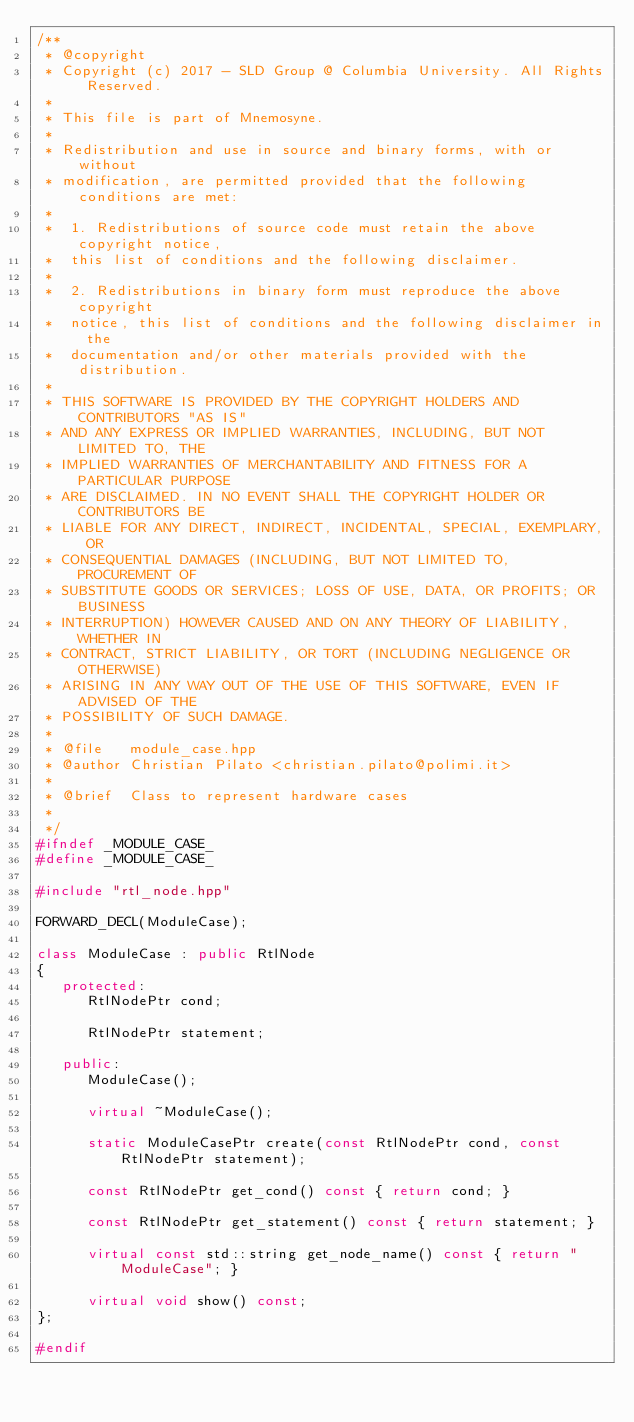<code> <loc_0><loc_0><loc_500><loc_500><_C++_>/**
 * @copyright
 * Copyright (c) 2017 - SLD Group @ Columbia University. All Rights Reserved.
 *
 * This file is part of Mnemosyne.
 *
 * Redistribution and use in source and binary forms, with or without
 * modification, are permitted provided that the following conditions are met:
 *
 *  1. Redistributions of source code must retain the above copyright notice,
 *  this list of conditions and the following disclaimer.
 *
 *  2. Redistributions in binary form must reproduce the above copyright
 *  notice, this list of conditions and the following disclaimer in the
 *  documentation and/or other materials provided with the distribution.
 *
 * THIS SOFTWARE IS PROVIDED BY THE COPYRIGHT HOLDERS AND CONTRIBUTORS "AS IS"
 * AND ANY EXPRESS OR IMPLIED WARRANTIES, INCLUDING, BUT NOT LIMITED TO, THE
 * IMPLIED WARRANTIES OF MERCHANTABILITY AND FITNESS FOR A PARTICULAR PURPOSE
 * ARE DISCLAIMED. IN NO EVENT SHALL THE COPYRIGHT HOLDER OR CONTRIBUTORS BE
 * LIABLE FOR ANY DIRECT, INDIRECT, INCIDENTAL, SPECIAL, EXEMPLARY, OR
 * CONSEQUENTIAL DAMAGES (INCLUDING, BUT NOT LIMITED TO, PROCUREMENT OF
 * SUBSTITUTE GOODS OR SERVICES; LOSS OF USE, DATA, OR PROFITS; OR BUSINESS
 * INTERRUPTION) HOWEVER CAUSED AND ON ANY THEORY OF LIABILITY, WHETHER IN
 * CONTRACT, STRICT LIABILITY, OR TORT (INCLUDING NEGLIGENCE OR OTHERWISE)
 * ARISING IN ANY WAY OUT OF THE USE OF THIS SOFTWARE, EVEN IF ADVISED OF THE
 * POSSIBILITY OF SUCH DAMAGE.
 *
 * @file   module_case.hpp
 * @author Christian Pilato <christian.pilato@polimi.it>
 *
 * @brief  Class to represent hardware cases
 *
 */
#ifndef _MODULE_CASE_
#define _MODULE_CASE_

#include "rtl_node.hpp"

FORWARD_DECL(ModuleCase);

class ModuleCase : public RtlNode
{
   protected:
      RtlNodePtr cond;

      RtlNodePtr statement;

   public:
      ModuleCase();

      virtual ~ModuleCase();

      static ModuleCasePtr create(const RtlNodePtr cond, const RtlNodePtr statement);

      const RtlNodePtr get_cond() const { return cond; }

      const RtlNodePtr get_statement() const { return statement; }

      virtual const std::string get_node_name() const { return "ModuleCase"; }

      virtual void show() const;
};

#endif
</code> 